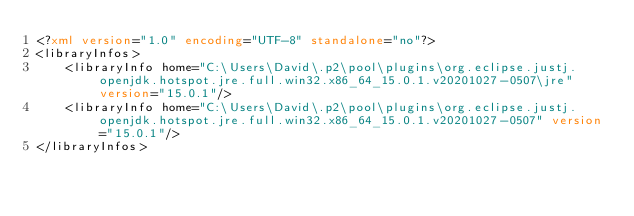Convert code to text. <code><loc_0><loc_0><loc_500><loc_500><_XML_><?xml version="1.0" encoding="UTF-8" standalone="no"?>
<libraryInfos>
    <libraryInfo home="C:\Users\David\.p2\pool\plugins\org.eclipse.justj.openjdk.hotspot.jre.full.win32.x86_64_15.0.1.v20201027-0507\jre" version="15.0.1"/>
    <libraryInfo home="C:\Users\David\.p2\pool\plugins\org.eclipse.justj.openjdk.hotspot.jre.full.win32.x86_64_15.0.1.v20201027-0507" version="15.0.1"/>
</libraryInfos>
</code> 